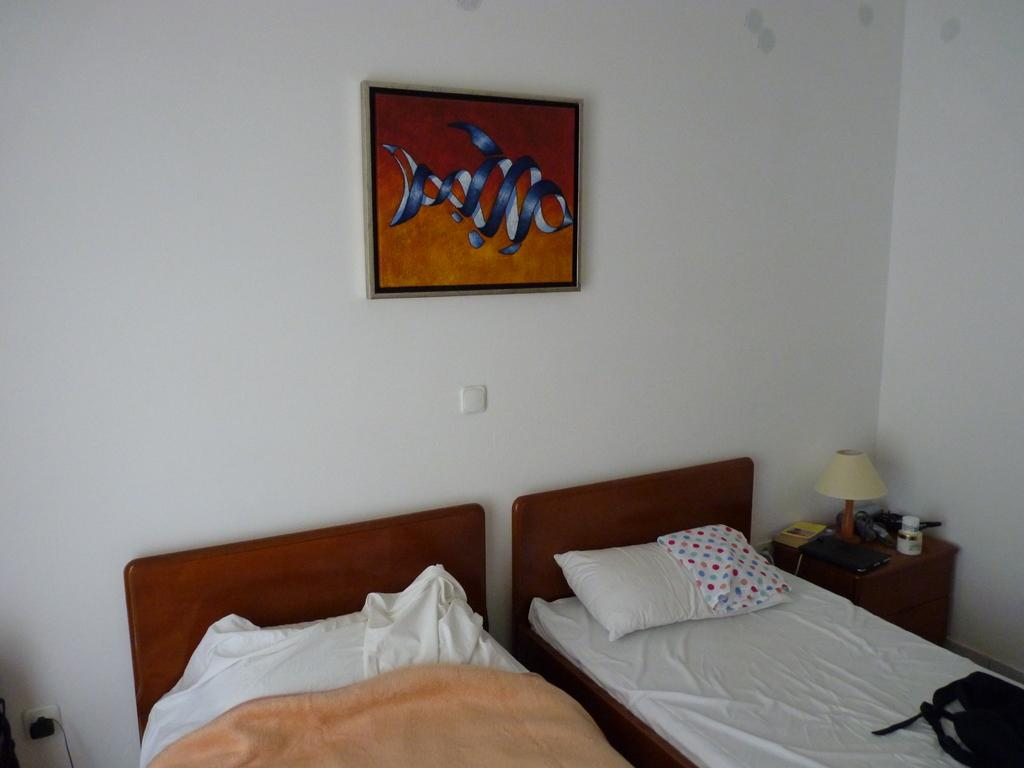What type of furniture is present in the image? There are beds in the image. What is placed on the beds for comfort? There is a pillow in the image. What can be seen in the background of the image? There is a wall and a frame in the background of the image. What is the source of light in the image? There is a lamp on a table in the image. What type of harmony can be heard in the image? There is no audible harmony present in the image, as it is a still image and not a video or audio recording. --- Facts: 1. There is a car in the image. 2. The car is red. 3. The car has four wheels. 4. There is a road in the image. 5. The road is paved. Absurd Topics: dance, ocean, bird Conversation: What is the main subject of the image? The main subject of the image is a car. What color is the car? The car is red. How many wheels does the car have? The car has four wheels. What type of surface can be seen in the image? There is a road in the image, and it is paved. Reasoning: Let's think step by step in order to produce the conversation. We start by identifying the main subject of the image, which is the car. Then, we describe the car's color and the number of wheels it has. Next, we mention the type of surface that can be seen in the image, which is a paved road. Absurd Question/Answer: Can you see any birds flying over the ocean in the image? There is no ocean or birds present in the image; it features a red car on a paved road. 